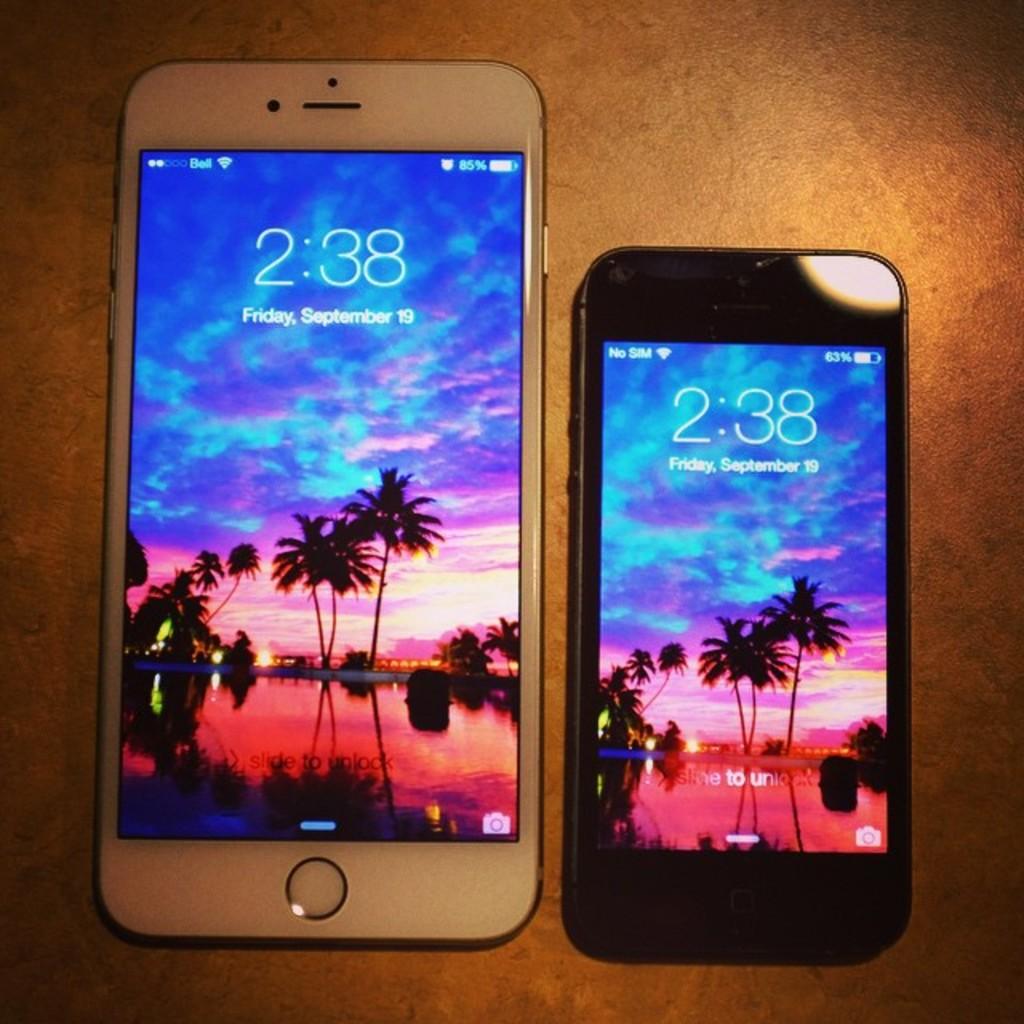What time is it?
Give a very brief answer. 2:38. What is the date shown?
Offer a very short reply. September 19. 